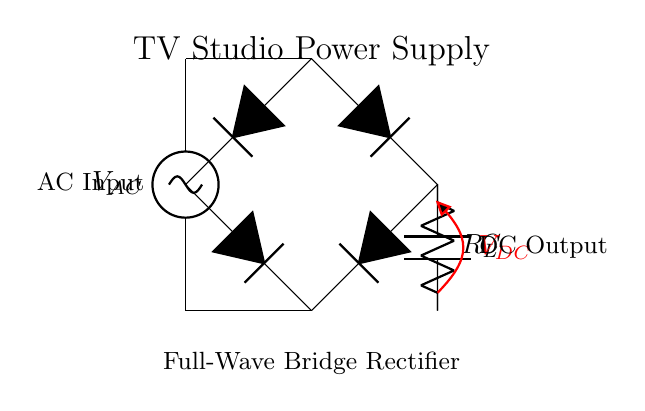What is the AC input voltage? The AC input voltage is represented by the symbol V_AC at the top-left of the circuit diagram. It indicates the source of alternating current feeding into the rectifier.
Answer: V_AC What type of rectifier is used in this circuit? The circuit diagram specifically includes a full-wave bridge rectifier made up of four diodes arranged in a bridge configuration, allowing it to convert AC to DC voltage effectively.
Answer: Full-wave bridge rectifier How many diodes are present in the circuit? There are four diodes used in the bridge rectifier configuration. Each diode is connected in such a way to allow current to flow during both halves of the AC cycle.
Answer: Four What is the purpose of the capacitor labeled C? The capacitor, labeled C, is used for smoothing the output voltage after rectification by reducing ripples in the DC supply. It charges when the voltage increases and discharges when the voltage drops, thereby providing a more stable DC output.
Answer: Smoothing DC voltage What does R_L represent in the circuit? R_L stands for the load resistor, which represents the load connected to the rectifier's output. It consumes the rectified DC power supplied by the circuit and is essential for the operation of the entire system.
Answer: Load resistor What is the DC output voltage location in the diagram? The DC output voltage is indicated by the symbol V_DC at the output, labeled in red, showing the point where the stabilized direct current voltage is available for use by connected devices.
Answer: V_DC 